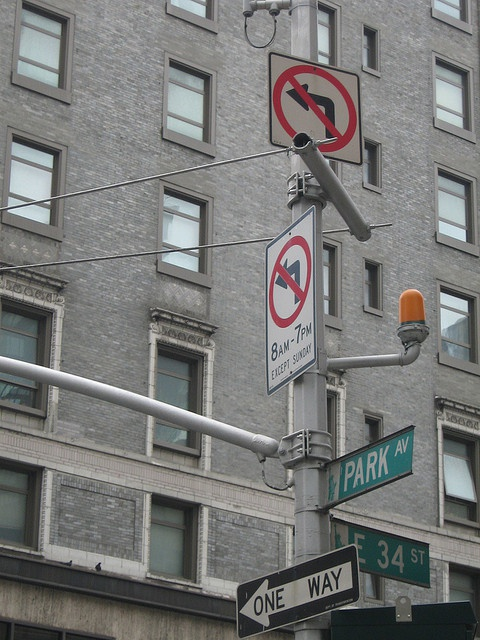Describe the objects in this image and their specific colors. I can see various objects in this image with different colors. 